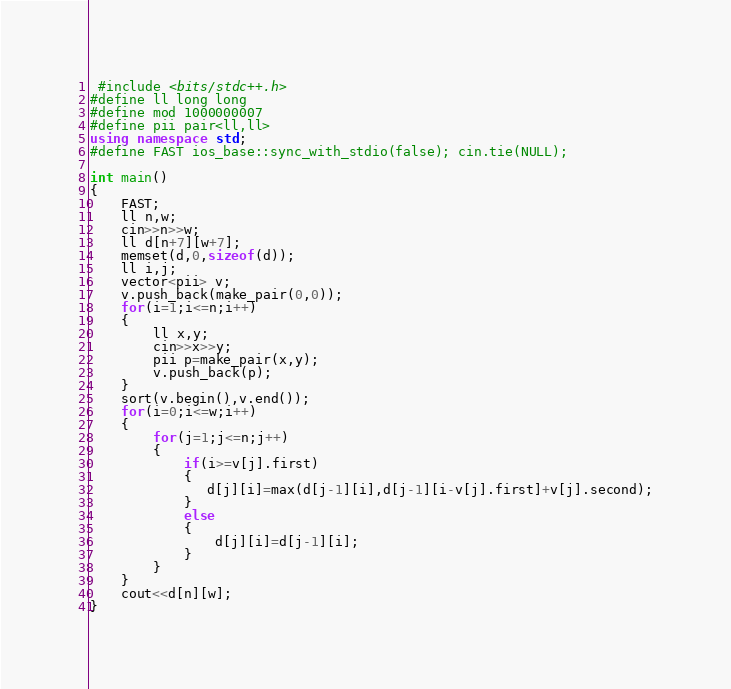Convert code to text. <code><loc_0><loc_0><loc_500><loc_500><_C++_> #include <bits/stdc++.h>
#define ll long long
#define mod 1000000007
#define pii pair<ll,ll> 
using namespace std;
#define FAST ios_base::sync_with_stdio(false); cin.tie(NULL);

int main() 
{
    FAST;
    ll n,w;
    cin>>n>>w;
    ll d[n+7][w+7];
    memset(d,0,sizeof(d));
    ll i,j;
    vector<pii> v;
    v.push_back(make_pair(0,0));
    for(i=1;i<=n;i++)
    {
        ll x,y;
        cin>>x>>y;
        pii p=make_pair(x,y);
        v.push_back(p);
    }
    sort(v.begin(),v.end());
    for(i=0;i<=w;i++)
    {
        for(j=1;j<=n;j++)
        {
            if(i>=v[j].first)
            {
               d[j][i]=max(d[j-1][i],d[j-1][i-v[j].first]+v[j].second);
            }
            else
            {
                d[j][i]=d[j-1][i];
            }
        }
    }
    cout<<d[n][w];
}</code> 